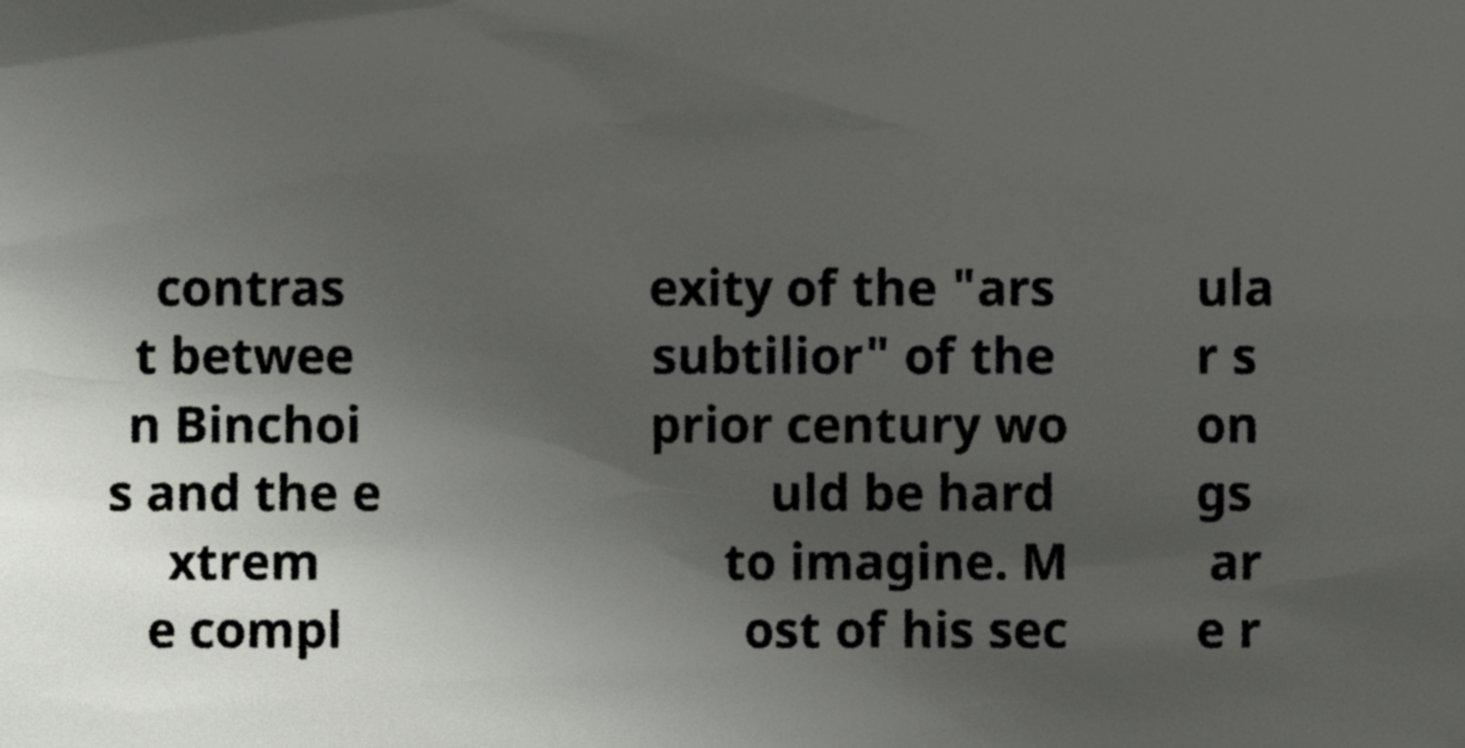What messages or text are displayed in this image? I need them in a readable, typed format. contras t betwee n Binchoi s and the e xtrem e compl exity of the "ars subtilior" of the prior century wo uld be hard to imagine. M ost of his sec ula r s on gs ar e r 